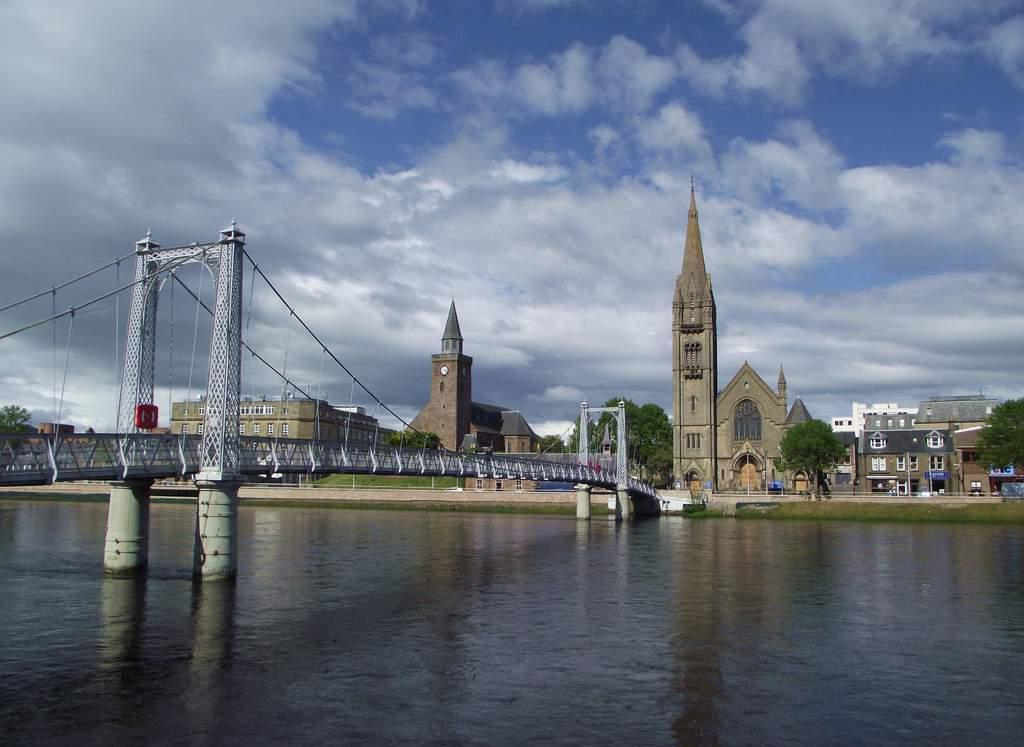What structure is located on the left side of the image? There is a bridge on the left side of the image. What can be seen in the image besides the bridge? There is water visible in the image. What is visible in the background of the image? There are trees and buildings in the background of the image. What is visible in the sky in the image? There are clouds in the sky. What type of meat is being grilled on the bridge in the image? There is no meat or grilling activity present in the image; it features a bridge, water, trees, buildings, and clouds. 